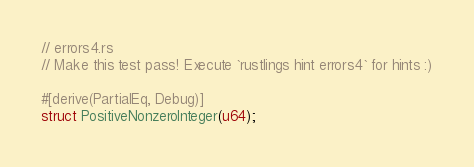<code> <loc_0><loc_0><loc_500><loc_500><_Rust_>// errors4.rs
// Make this test pass! Execute `rustlings hint errors4` for hints :)

#[derive(PartialEq, Debug)]
struct PositiveNonzeroInteger(u64);
</code> 